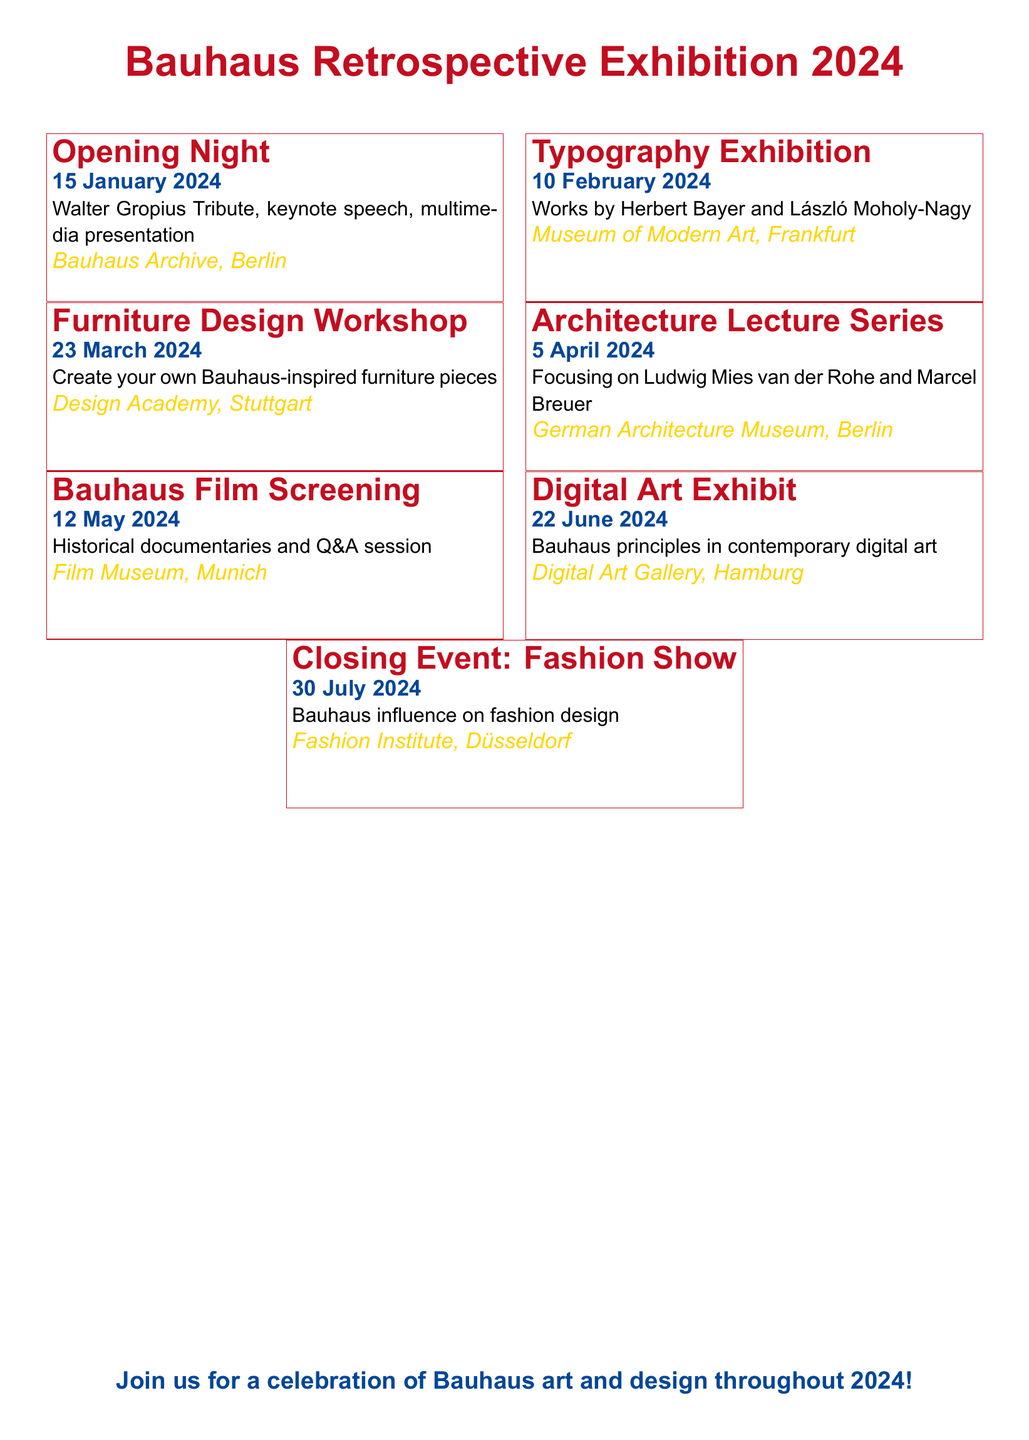What is the date of the Opening Night event? The date of the Opening Night event is mentioned clearly in the document.
Answer: 15 January 2024 Who is celebrated during the Opening Night? The document specifies that Walter Gropius is honored during the Opening Night event.
Answer: Walter Gropius Where will the Typography Exhibition be held? The location for the Typography Exhibition is provided in the event details.
Answer: Museum of Modern Art, Frankfurt What type of workshop is scheduled for March 2024? The document describes the nature of the workshop scheduled for that month.
Answer: Furniture Design Workshop Which event features a Q&A session? The document indicates that the Bauhaus Film Screening will include a Q&A session.
Answer: Bauhaus Film Screening How many months does the exhibition schedule cover? The schedule starts in January and ends in July, which is a span of months.
Answer: 7 months Which event highlights the influence on fashion design? The document specifies the final event that focuses on fashion design.
Answer: Closing Event: Fashion Show What is the theme of the Digital Art Exhibit? The theme for the Digital Art Exhibit is outlined in the description provided.
Answer: Bauhaus principles in contemporary digital art 